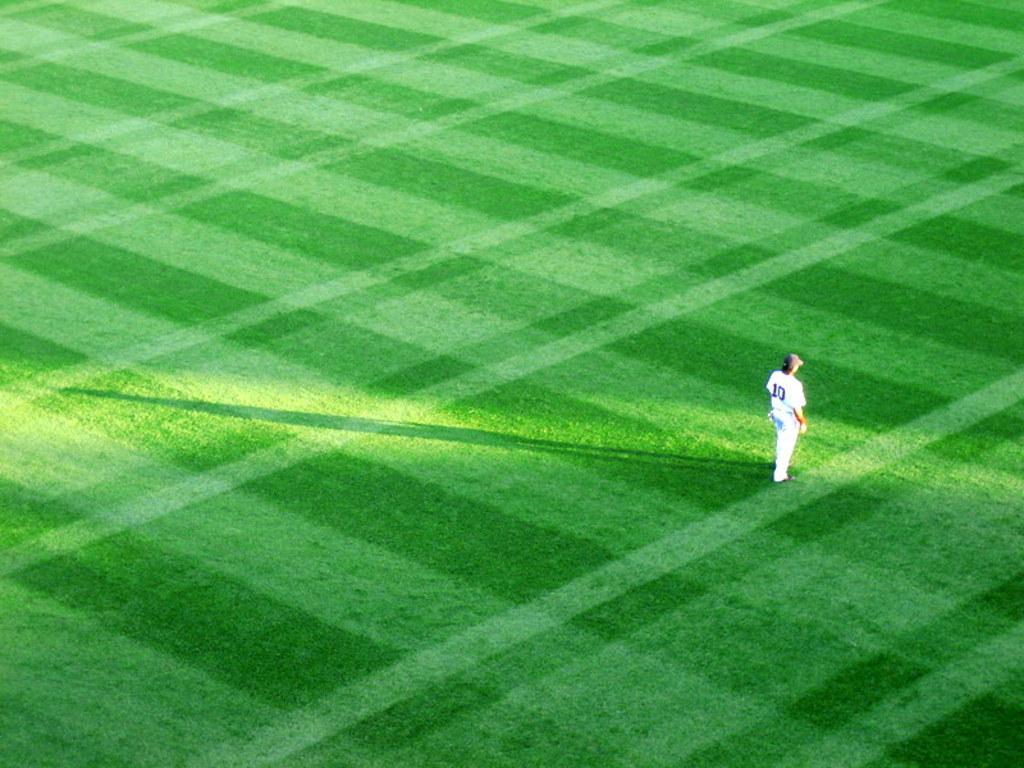In one or two sentences, can you explain what this image depicts? This is a playing ground. On the right side there is a person wearing a white color dress, cap on the head and standing facing towards the right side. 